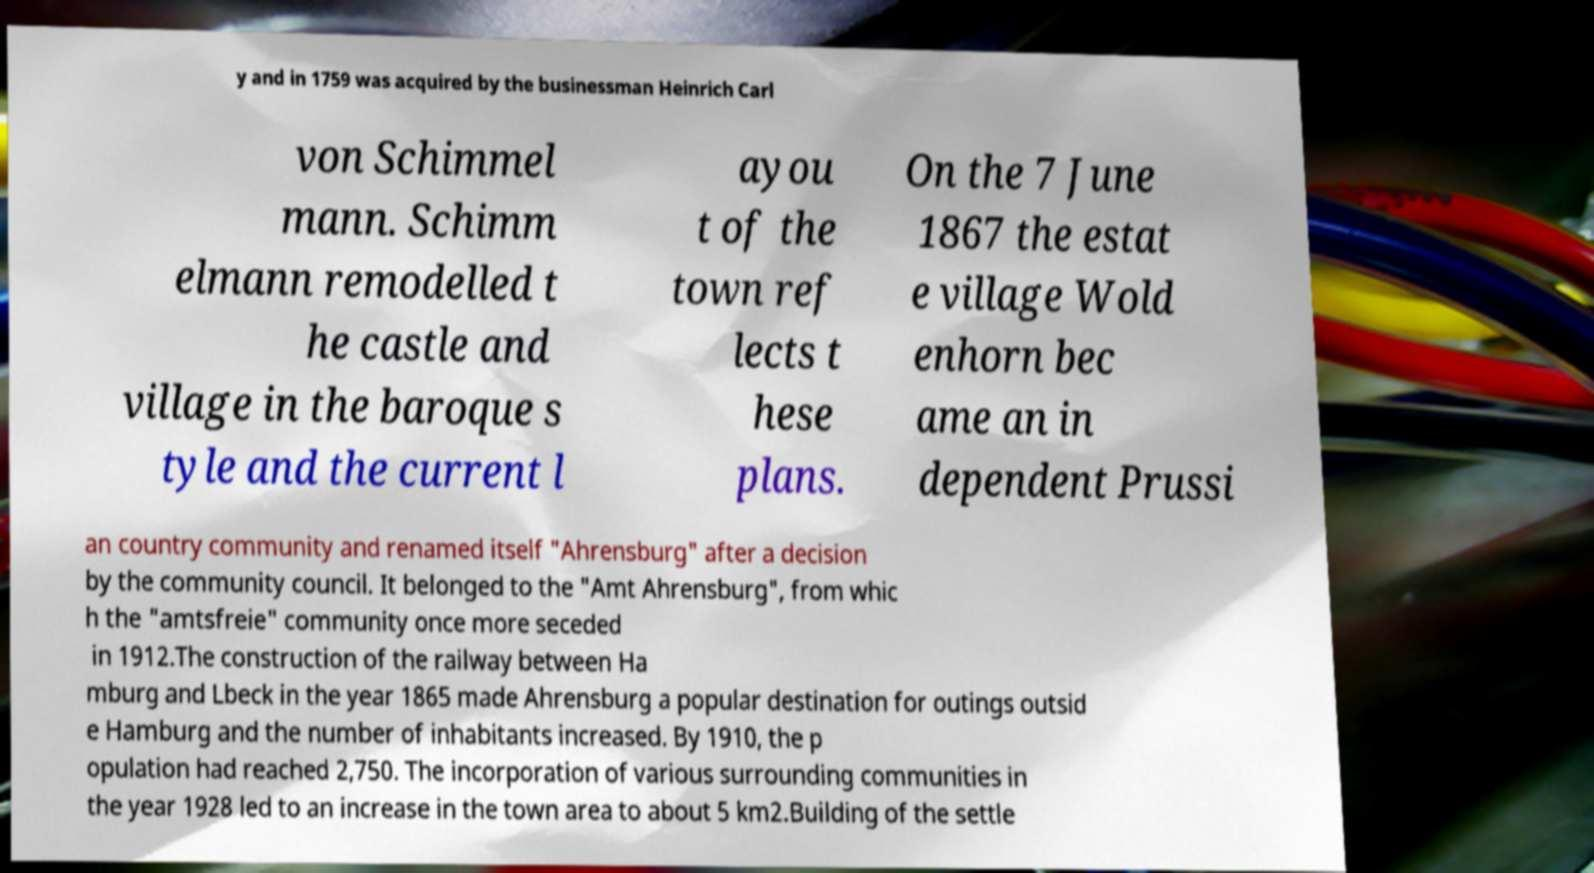Could you assist in decoding the text presented in this image and type it out clearly? y and in 1759 was acquired by the businessman Heinrich Carl von Schimmel mann. Schimm elmann remodelled t he castle and village in the baroque s tyle and the current l ayou t of the town ref lects t hese plans. On the 7 June 1867 the estat e village Wold enhorn bec ame an in dependent Prussi an country community and renamed itself "Ahrensburg" after a decision by the community council. It belonged to the "Amt Ahrensburg", from whic h the "amtsfreie" community once more seceded in 1912.The construction of the railway between Ha mburg and Lbeck in the year 1865 made Ahrensburg a popular destination for outings outsid e Hamburg and the number of inhabitants increased. By 1910, the p opulation had reached 2,750. The incorporation of various surrounding communities in the year 1928 led to an increase in the town area to about 5 km2.Building of the settle 